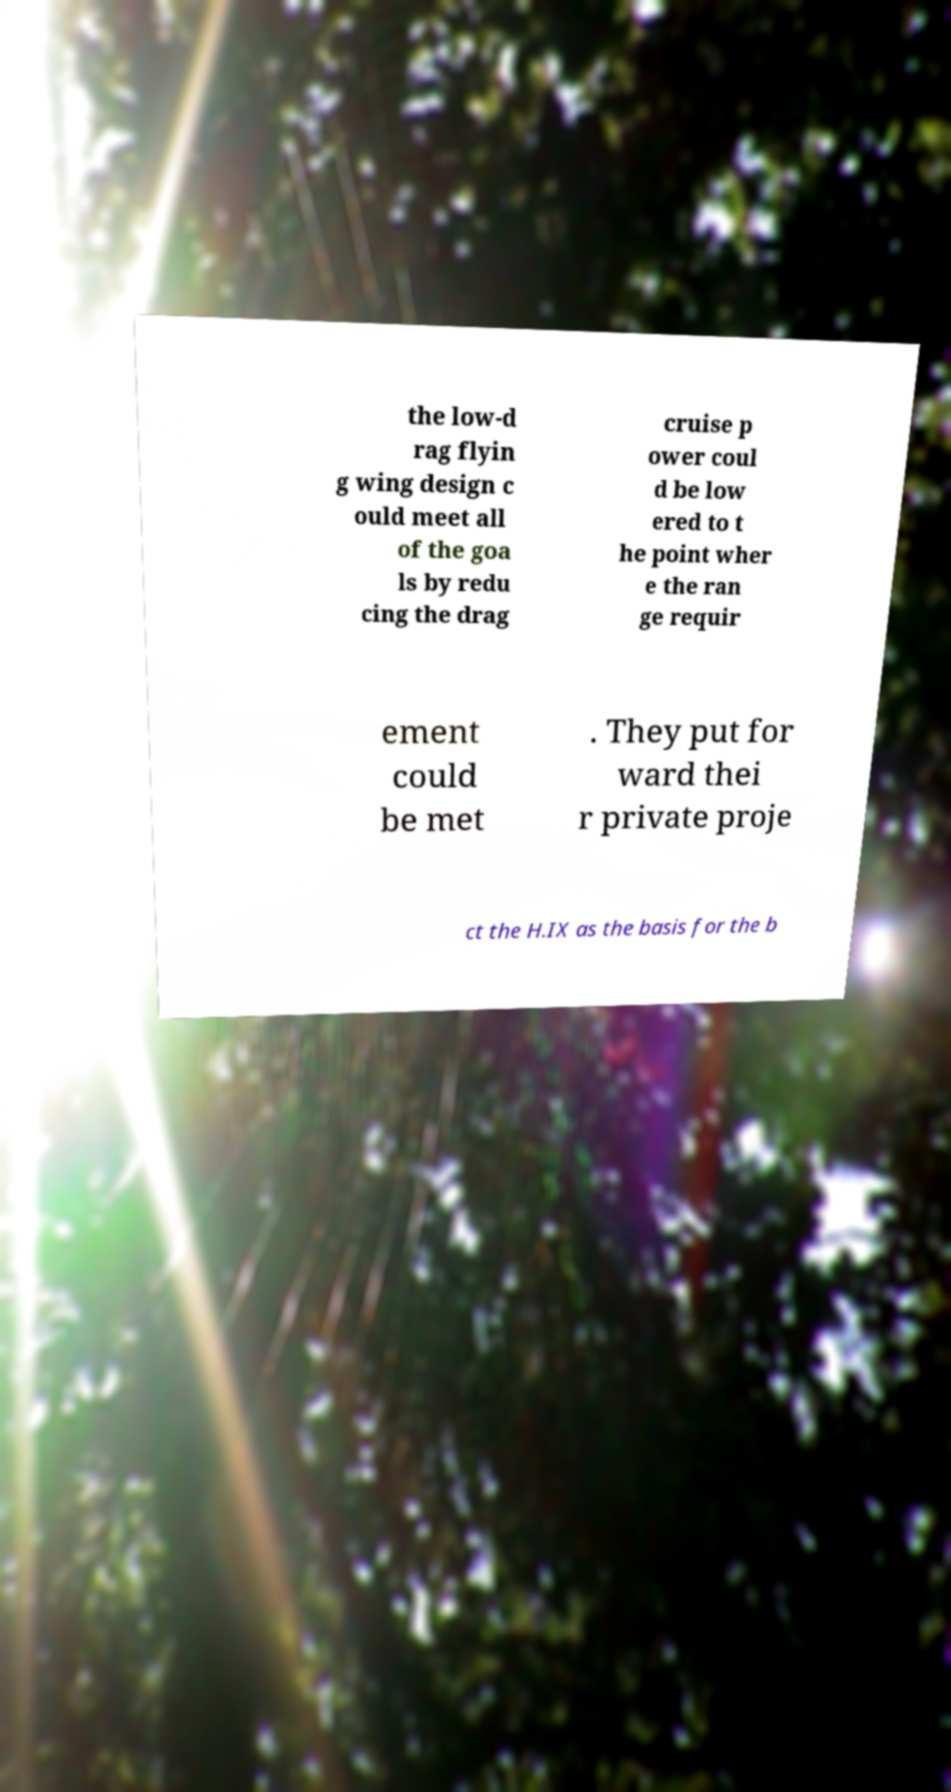Could you extract and type out the text from this image? the low-d rag flyin g wing design c ould meet all of the goa ls by redu cing the drag cruise p ower coul d be low ered to t he point wher e the ran ge requir ement could be met . They put for ward thei r private proje ct the H.IX as the basis for the b 